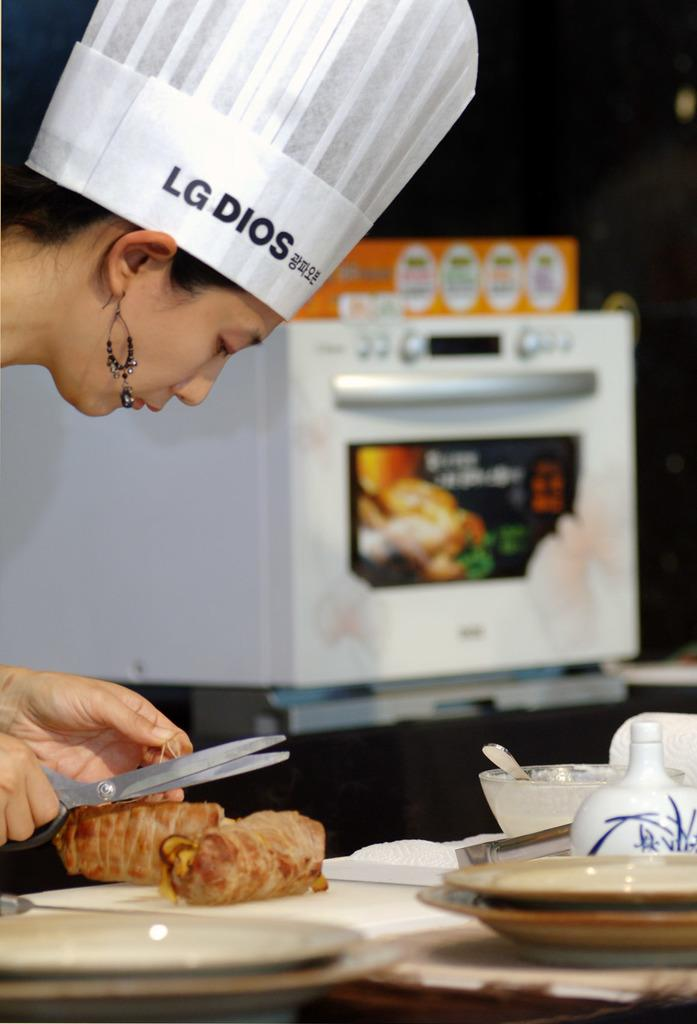<image>
Share a concise interpretation of the image provided. a woman wearing a hat that says 'lg dios' on it 